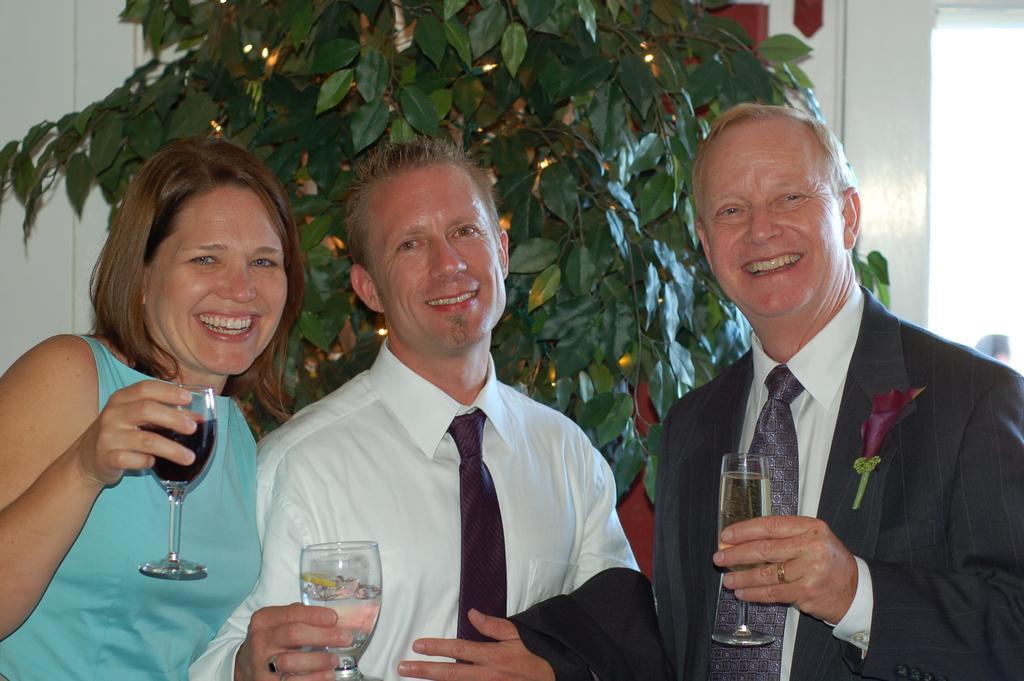Can you describe this image briefly? On the background we can see a plant. Here we can see three persons standing, holding drinking glasses in their hands and they are giving a nice pose with a smile to the camera. 